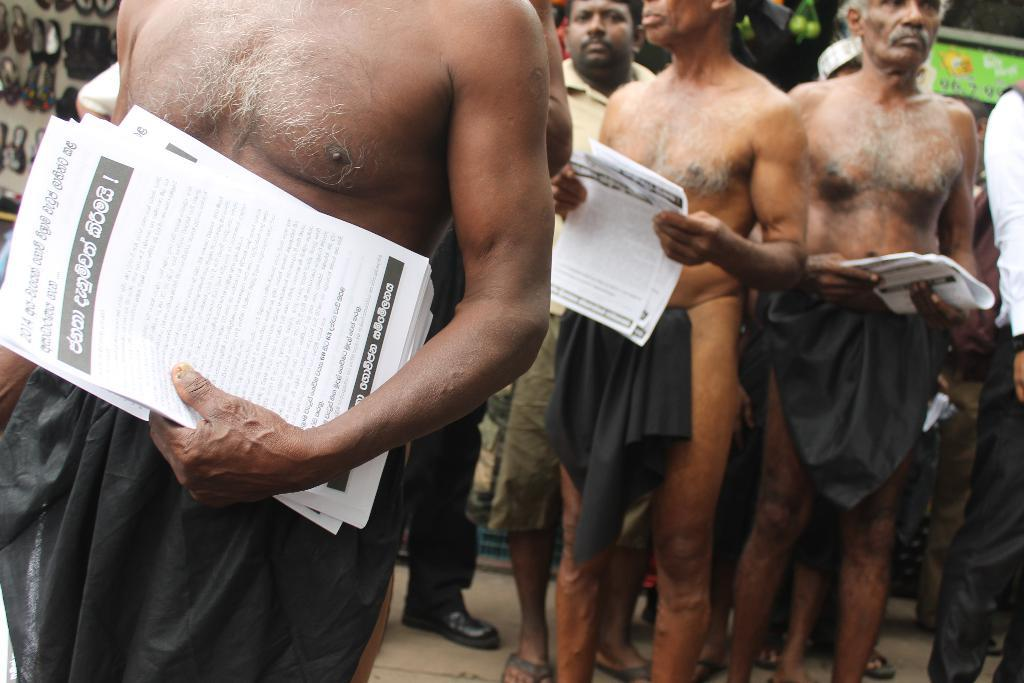What are the men in the image doing? The men in the image are standing and holding papers. Can you describe any objects or items visible in the image? There are footwear on the left side of the image. What type of waste can be seen in the image? There is no waste visible in the image. What type of smile can be seen on the men's faces in the image? The image does not show the men's faces, so it is not possible to determine if they are smiling or not. 